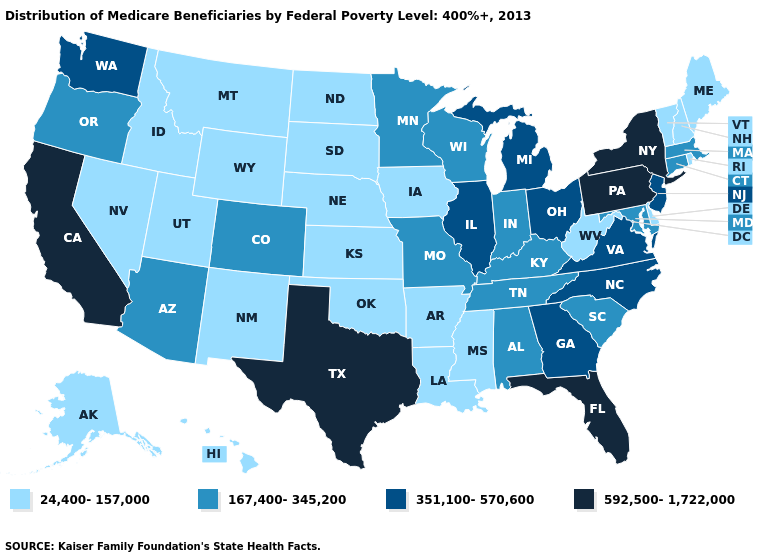Name the states that have a value in the range 24,400-157,000?
Concise answer only. Alaska, Arkansas, Delaware, Hawaii, Idaho, Iowa, Kansas, Louisiana, Maine, Mississippi, Montana, Nebraska, Nevada, New Hampshire, New Mexico, North Dakota, Oklahoma, Rhode Island, South Dakota, Utah, Vermont, West Virginia, Wyoming. Does Connecticut have the lowest value in the USA?
Short answer required. No. Name the states that have a value in the range 351,100-570,600?
Be succinct. Georgia, Illinois, Michigan, New Jersey, North Carolina, Ohio, Virginia, Washington. What is the highest value in the MidWest ?
Be succinct. 351,100-570,600. Among the states that border New Hampshire , does Massachusetts have the highest value?
Answer briefly. Yes. What is the lowest value in the South?
Concise answer only. 24,400-157,000. Among the states that border New Hampshire , does Maine have the highest value?
Quick response, please. No. Does North Carolina have the highest value in the South?
Short answer required. No. Does the map have missing data?
Short answer required. No. Name the states that have a value in the range 167,400-345,200?
Give a very brief answer. Alabama, Arizona, Colorado, Connecticut, Indiana, Kentucky, Maryland, Massachusetts, Minnesota, Missouri, Oregon, South Carolina, Tennessee, Wisconsin. What is the value of Kentucky?
Give a very brief answer. 167,400-345,200. What is the value of Tennessee?
Write a very short answer. 167,400-345,200. What is the value of Oklahoma?
Short answer required. 24,400-157,000. What is the lowest value in the West?
Quick response, please. 24,400-157,000. What is the value of West Virginia?
Give a very brief answer. 24,400-157,000. 